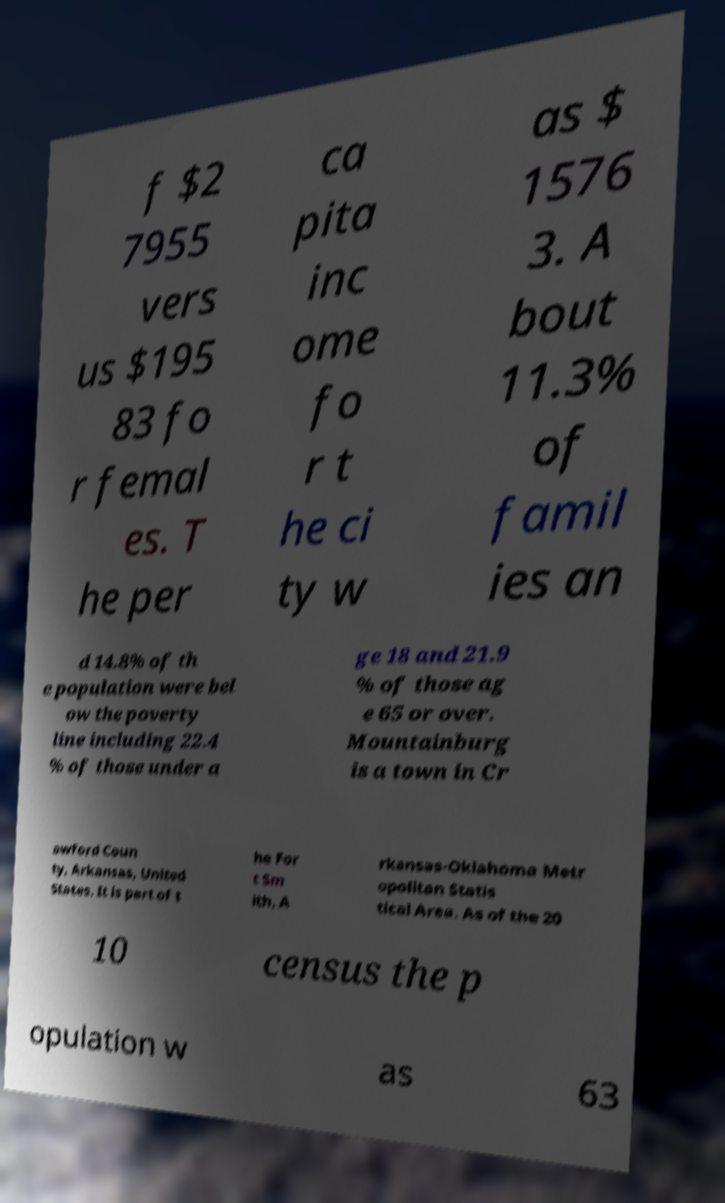What messages or text are displayed in this image? I need them in a readable, typed format. f $2 7955 vers us $195 83 fo r femal es. T he per ca pita inc ome fo r t he ci ty w as $ 1576 3. A bout 11.3% of famil ies an d 14.8% of th e population were bel ow the poverty line including 22.4 % of those under a ge 18 and 21.9 % of those ag e 65 or over. Mountainburg is a town in Cr awford Coun ty, Arkansas, United States. It is part of t he For t Sm ith, A rkansas-Oklahoma Metr opolitan Statis tical Area. As of the 20 10 census the p opulation w as 63 